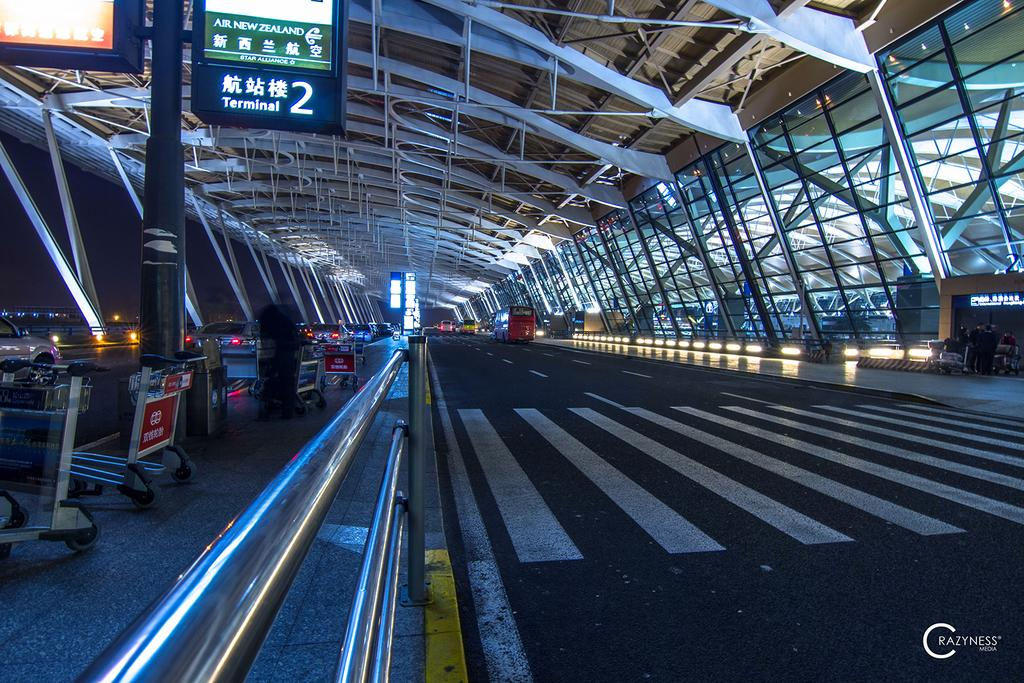What type of pathway is present in the image? There is a road in the image. What can be seen on the left side of the image? There is a handrail on the left side of the image. What type of transportation is visible in the image? There are trolleys visible in the image. What material is used for the roof in the image? The roof in the image is made of metal. What type of location might the image be set in? The image appears to be set at an airport. What type of beam is holding up the attraction in the image? There is no attraction or beam present in the image. How far can you stretch your arms in the image? The image does not depict a person or any action involving stretching arms. 